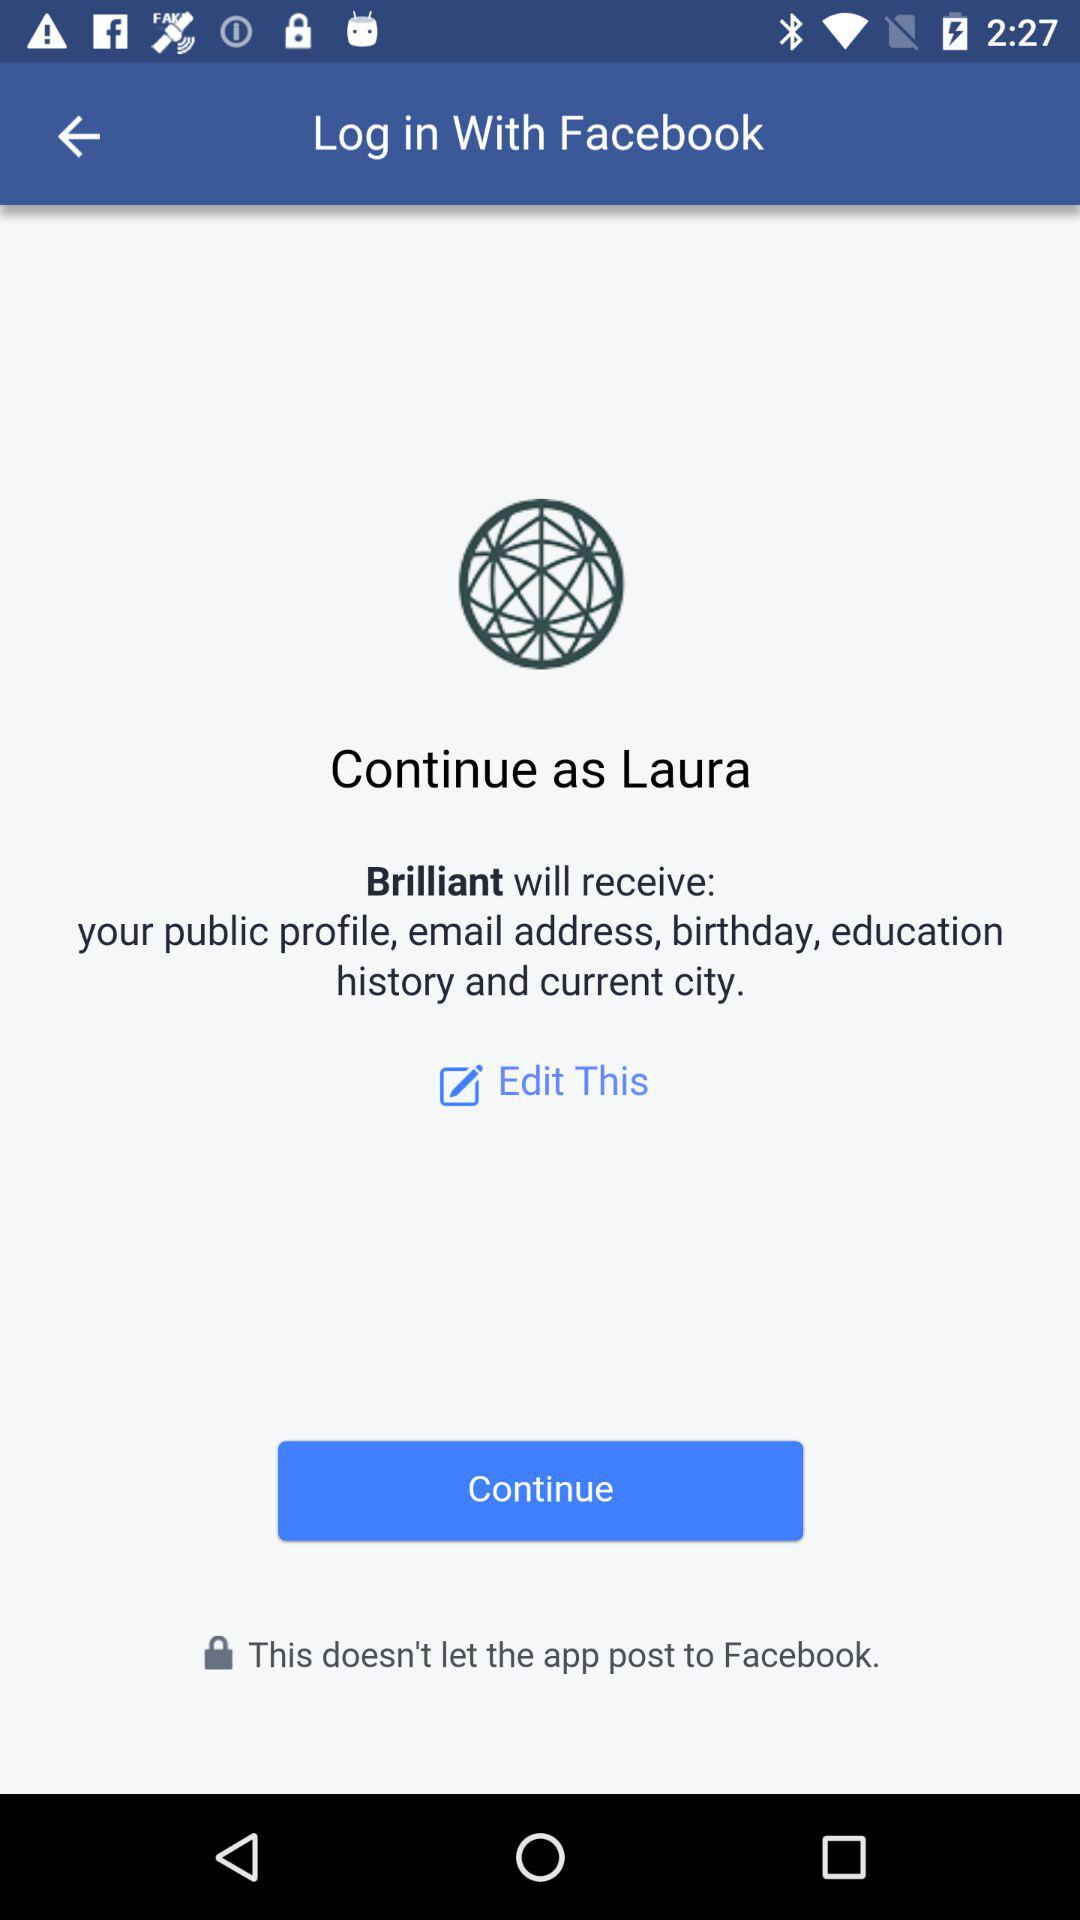What is the username? The username is Laura. 